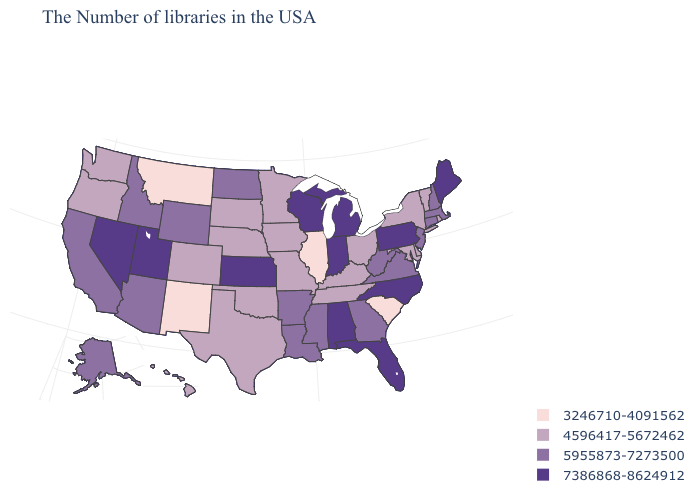Does the map have missing data?
Quick response, please. No. Does Pennsylvania have the same value as Florida?
Concise answer only. Yes. What is the highest value in the South ?
Be succinct. 7386868-8624912. Name the states that have a value in the range 5955873-7273500?
Give a very brief answer. Massachusetts, New Hampshire, Connecticut, New Jersey, Virginia, West Virginia, Georgia, Mississippi, Louisiana, Arkansas, North Dakota, Wyoming, Arizona, Idaho, California, Alaska. What is the value of New Jersey?
Quick response, please. 5955873-7273500. Name the states that have a value in the range 5955873-7273500?
Quick response, please. Massachusetts, New Hampshire, Connecticut, New Jersey, Virginia, West Virginia, Georgia, Mississippi, Louisiana, Arkansas, North Dakota, Wyoming, Arizona, Idaho, California, Alaska. What is the value of South Carolina?
Keep it brief. 3246710-4091562. What is the lowest value in the Northeast?
Write a very short answer. 4596417-5672462. What is the highest value in the Northeast ?
Short answer required. 7386868-8624912. Which states hav the highest value in the MidWest?
Keep it brief. Michigan, Indiana, Wisconsin, Kansas. What is the value of North Carolina?
Concise answer only. 7386868-8624912. Name the states that have a value in the range 4596417-5672462?
Keep it brief. Rhode Island, Vermont, New York, Delaware, Maryland, Ohio, Kentucky, Tennessee, Missouri, Minnesota, Iowa, Nebraska, Oklahoma, Texas, South Dakota, Colorado, Washington, Oregon, Hawaii. What is the value of Iowa?
Quick response, please. 4596417-5672462. Name the states that have a value in the range 3246710-4091562?
Short answer required. South Carolina, Illinois, New Mexico, Montana. Name the states that have a value in the range 3246710-4091562?
Be succinct. South Carolina, Illinois, New Mexico, Montana. 